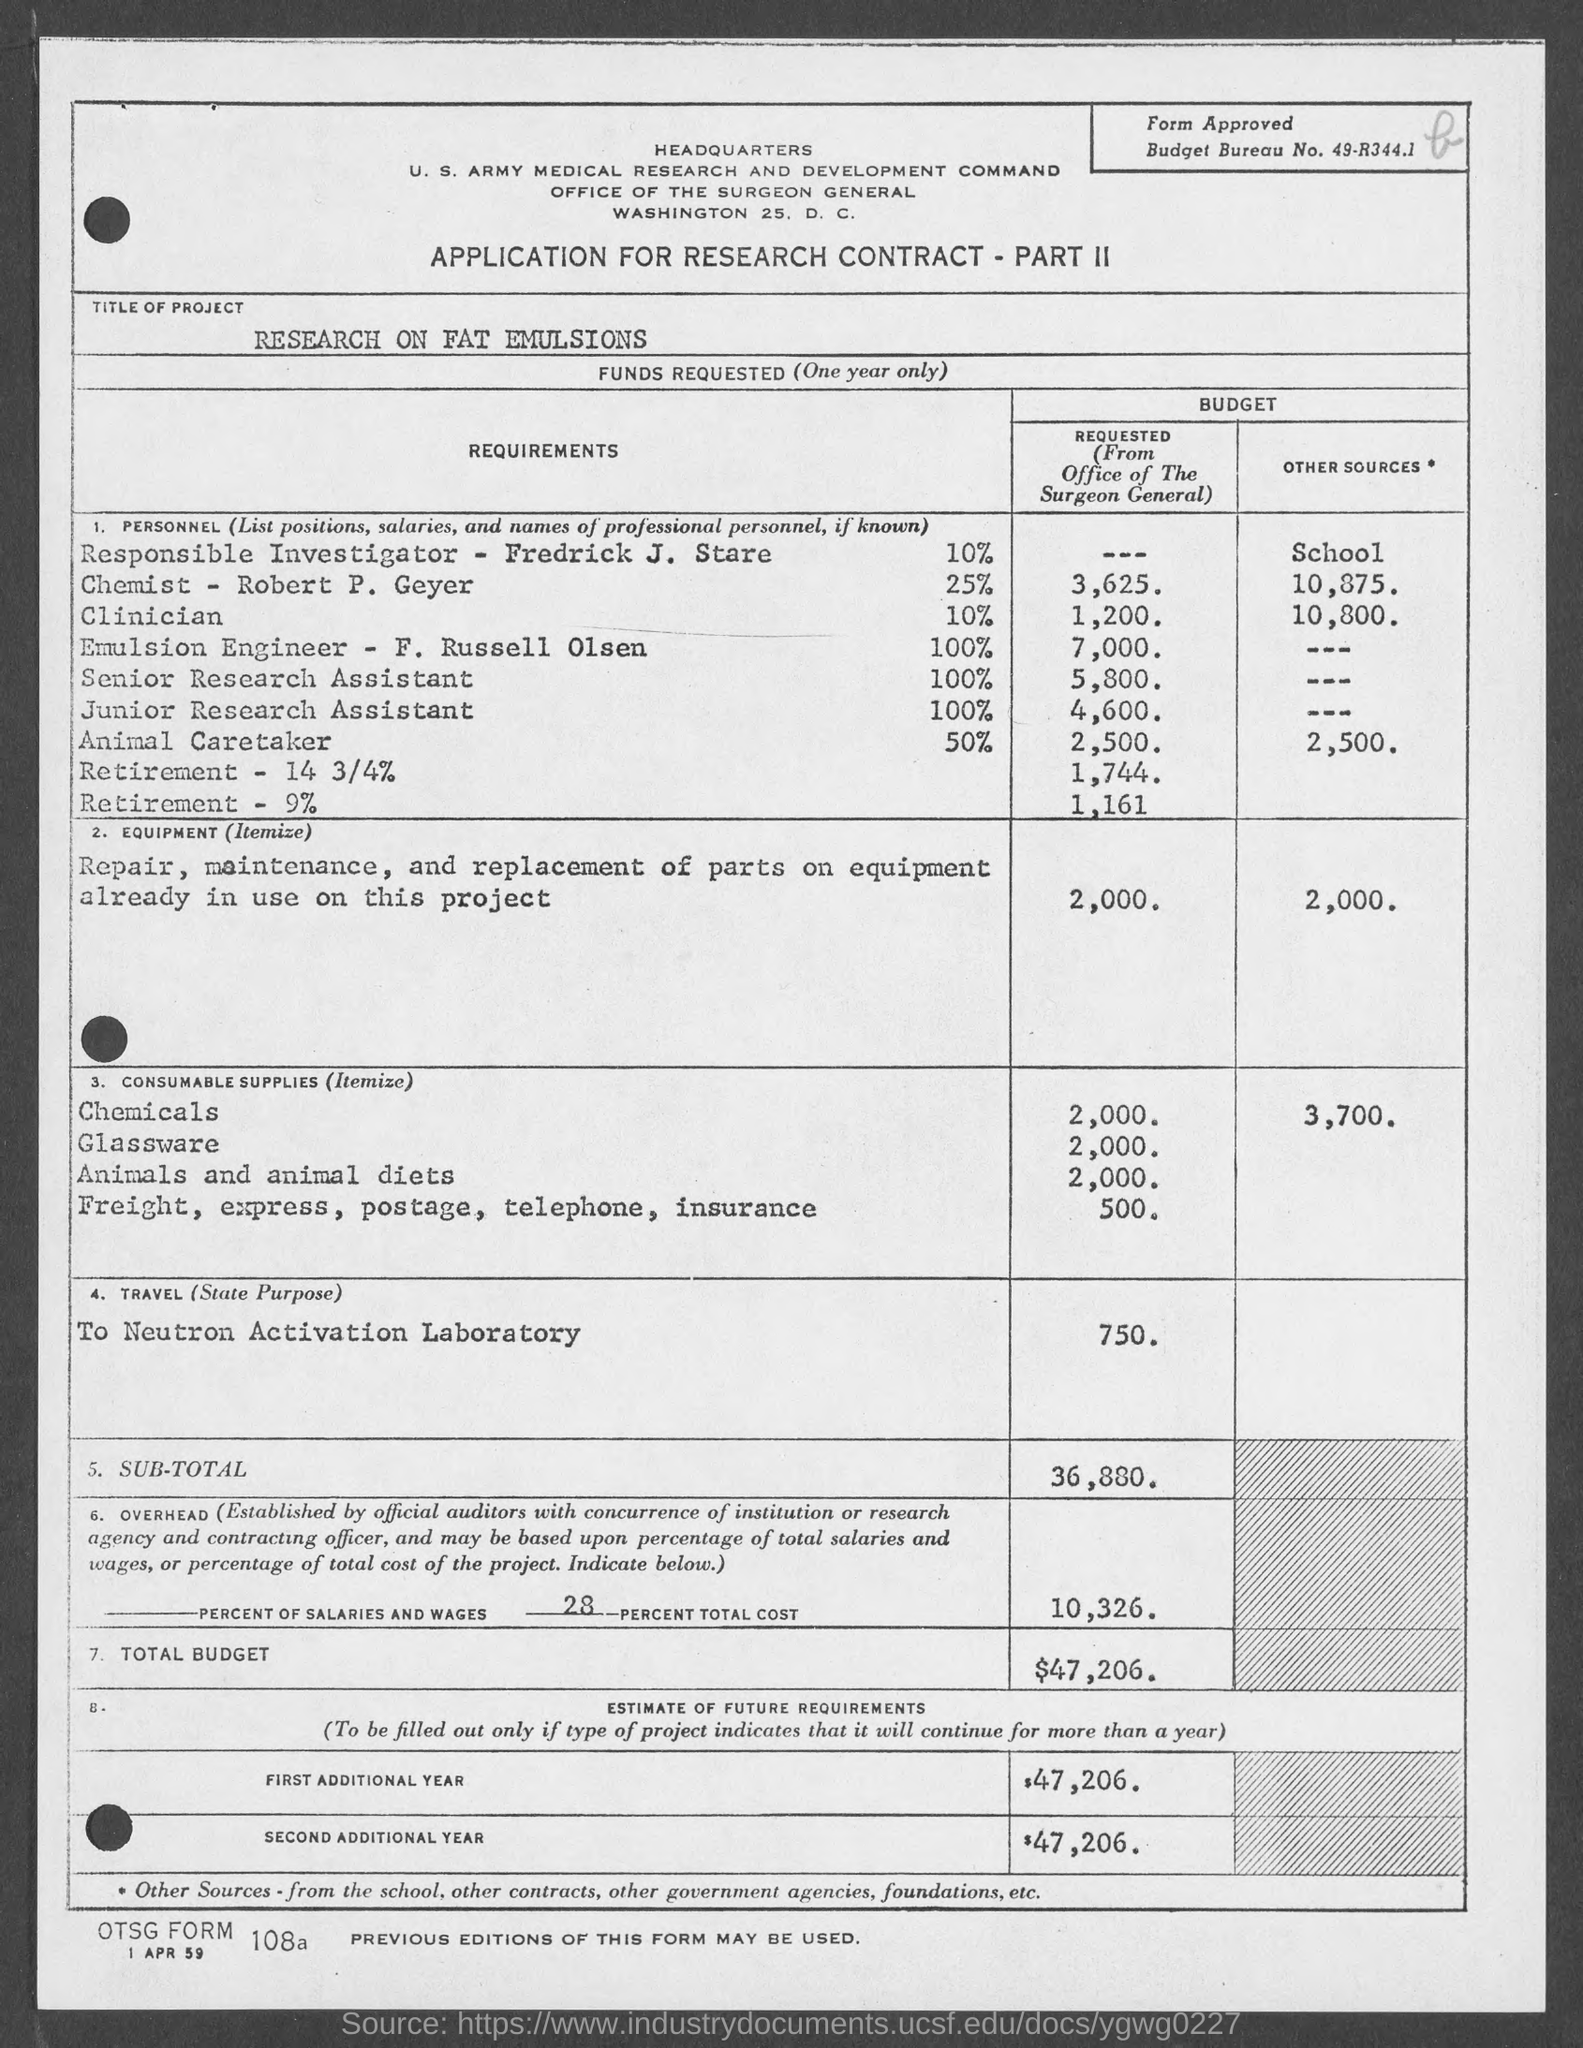What is the budget bureau no.?
Your answer should be compact. 49-R344.1. What is the application for ?
Your answer should be very brief. Research Contract- Part II. What is the total budget?
Make the answer very short. $47,206. What is first additional year budget?
Ensure brevity in your answer.  $47,206. What is second additional year budget?
Give a very brief answer. $47,206. What is the address of office of the surgeon general ?
Your response must be concise. Washington 25. D.C. What is the date at bottom of the page?
Make the answer very short. 1 APR 59. What is otsg form no.?
Provide a succinct answer. 108a. 